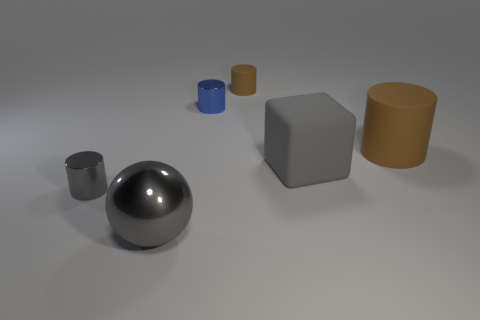There is a brown matte object left of the large cylinder; is its shape the same as the big thing that is left of the tiny brown matte cylinder?
Ensure brevity in your answer.  No. There is a small cylinder that is the same color as the big rubber cylinder; what material is it?
Provide a succinct answer. Rubber. Is there a large green rubber cube?
Your answer should be compact. No. There is a tiny gray thing that is the same shape as the big brown matte object; what material is it?
Your response must be concise. Metal. There is a blue metallic cylinder; are there any small gray metallic cylinders to the right of it?
Make the answer very short. No. Does the gray object right of the tiny brown matte object have the same material as the tiny gray thing?
Your response must be concise. No. Are there any metallic cylinders of the same color as the tiny matte object?
Your response must be concise. No. What shape is the large gray rubber object?
Make the answer very short. Cube. There is a tiny metallic cylinder that is left of the small shiny thing that is behind the small gray metallic object; what color is it?
Offer a very short reply. Gray. How big is the blue metal thing left of the block?
Give a very brief answer. Small. 